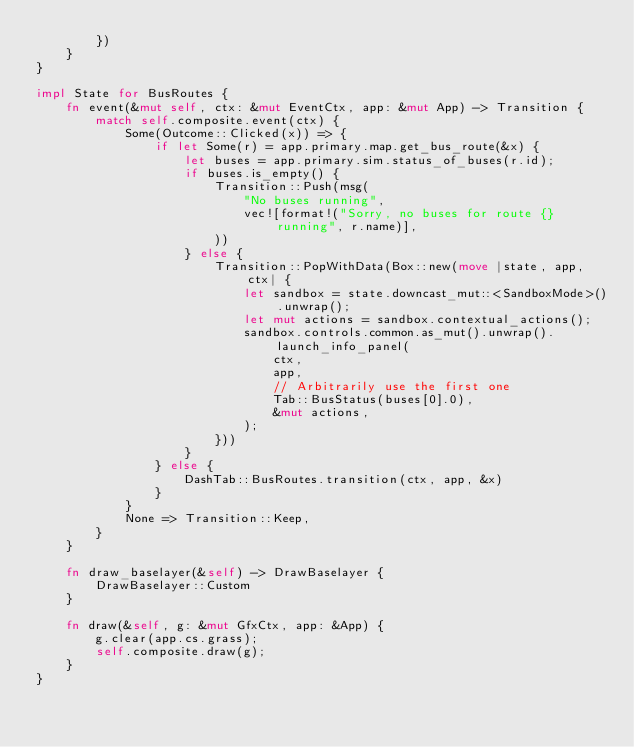Convert code to text. <code><loc_0><loc_0><loc_500><loc_500><_Rust_>        })
    }
}

impl State for BusRoutes {
    fn event(&mut self, ctx: &mut EventCtx, app: &mut App) -> Transition {
        match self.composite.event(ctx) {
            Some(Outcome::Clicked(x)) => {
                if let Some(r) = app.primary.map.get_bus_route(&x) {
                    let buses = app.primary.sim.status_of_buses(r.id);
                    if buses.is_empty() {
                        Transition::Push(msg(
                            "No buses running",
                            vec![format!("Sorry, no buses for route {} running", r.name)],
                        ))
                    } else {
                        Transition::PopWithData(Box::new(move |state, app, ctx| {
                            let sandbox = state.downcast_mut::<SandboxMode>().unwrap();
                            let mut actions = sandbox.contextual_actions();
                            sandbox.controls.common.as_mut().unwrap().launch_info_panel(
                                ctx,
                                app,
                                // Arbitrarily use the first one
                                Tab::BusStatus(buses[0].0),
                                &mut actions,
                            );
                        }))
                    }
                } else {
                    DashTab::BusRoutes.transition(ctx, app, &x)
                }
            }
            None => Transition::Keep,
        }
    }

    fn draw_baselayer(&self) -> DrawBaselayer {
        DrawBaselayer::Custom
    }

    fn draw(&self, g: &mut GfxCtx, app: &App) {
        g.clear(app.cs.grass);
        self.composite.draw(g);
    }
}
</code> 